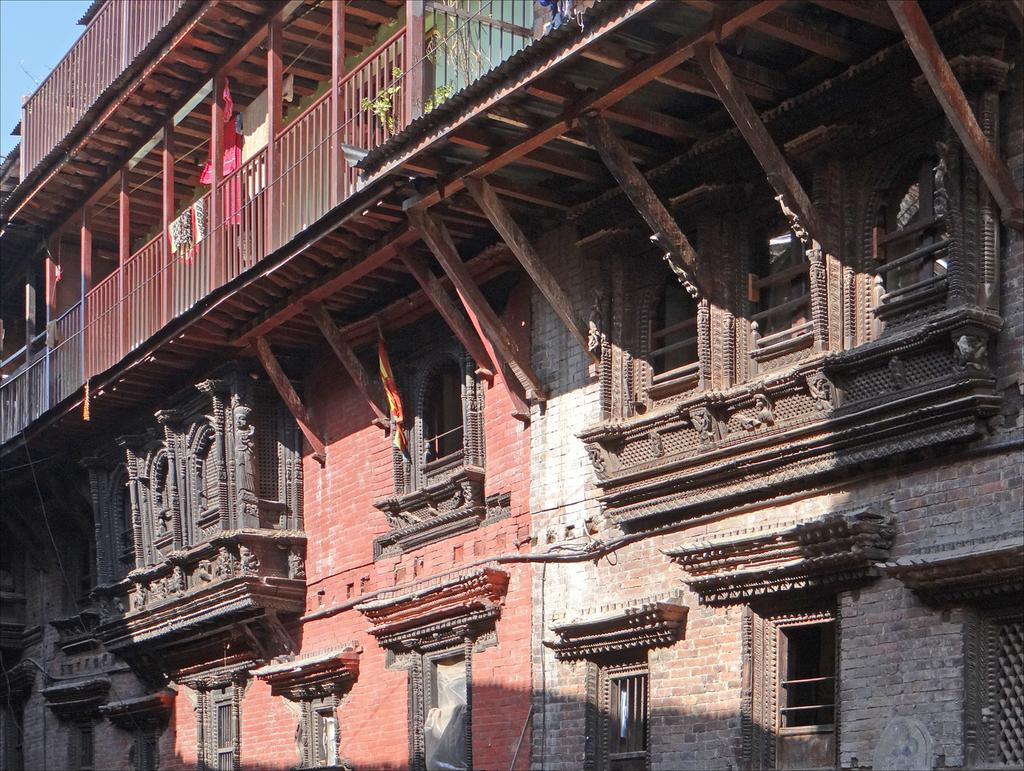What type of structure is present in the image? There is a building in the image. What architectural features can be seen on the building? The building has windows, pillars, iron grilles, and roofs. Are there any items visible on the balcony of the building? Yes, there are clothes and a plant in the balcony. What can be seen in the background of the image? The sky is visible in the background. How many oranges are hanging from the seed in the image? There are no oranges or seeds present in the image. What type of alley can be seen behind the building in the image? There is no alley visible in the image; only the building and the sky are present. 